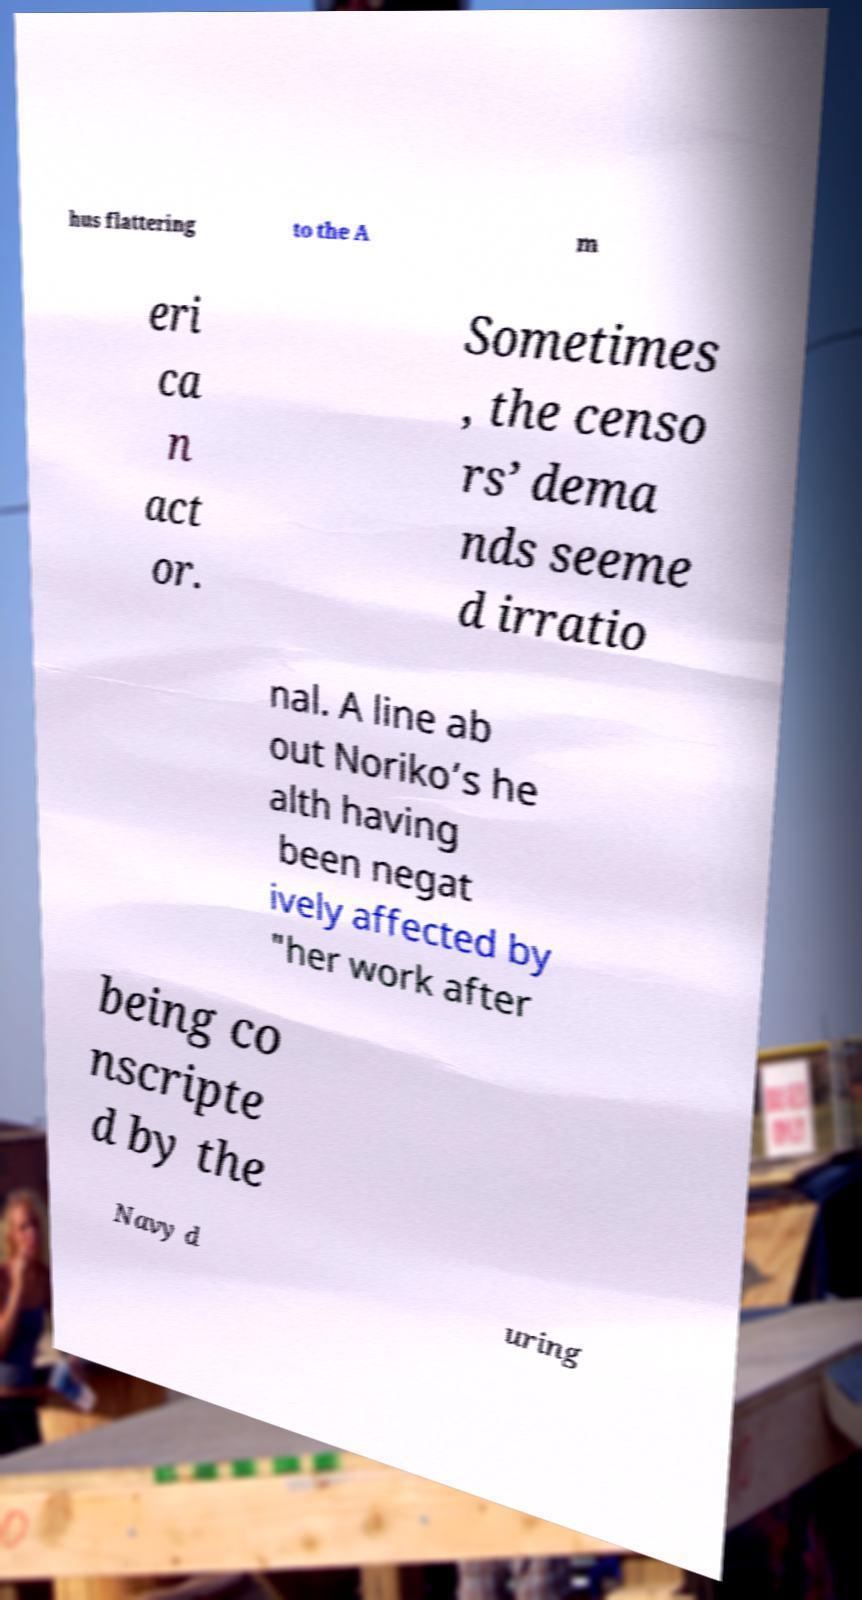What messages or text are displayed in this image? I need them in a readable, typed format. hus flattering to the A m eri ca n act or. Sometimes , the censo rs’ dema nds seeme d irratio nal. A line ab out Noriko’s he alth having been negat ively affected by "her work after being co nscripte d by the Navy d uring 